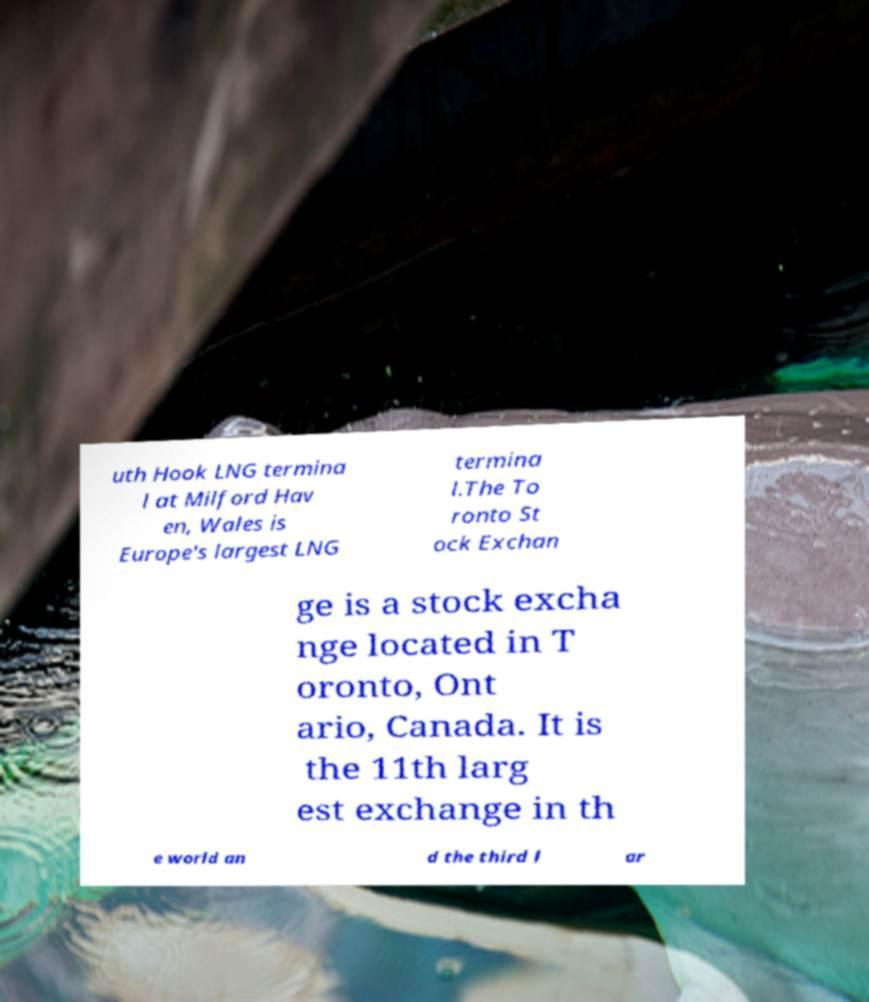Could you extract and type out the text from this image? uth Hook LNG termina l at Milford Hav en, Wales is Europe's largest LNG termina l.The To ronto St ock Exchan ge is a stock excha nge located in T oronto, Ont ario, Canada. It is the 11th larg est exchange in th e world an d the third l ar 